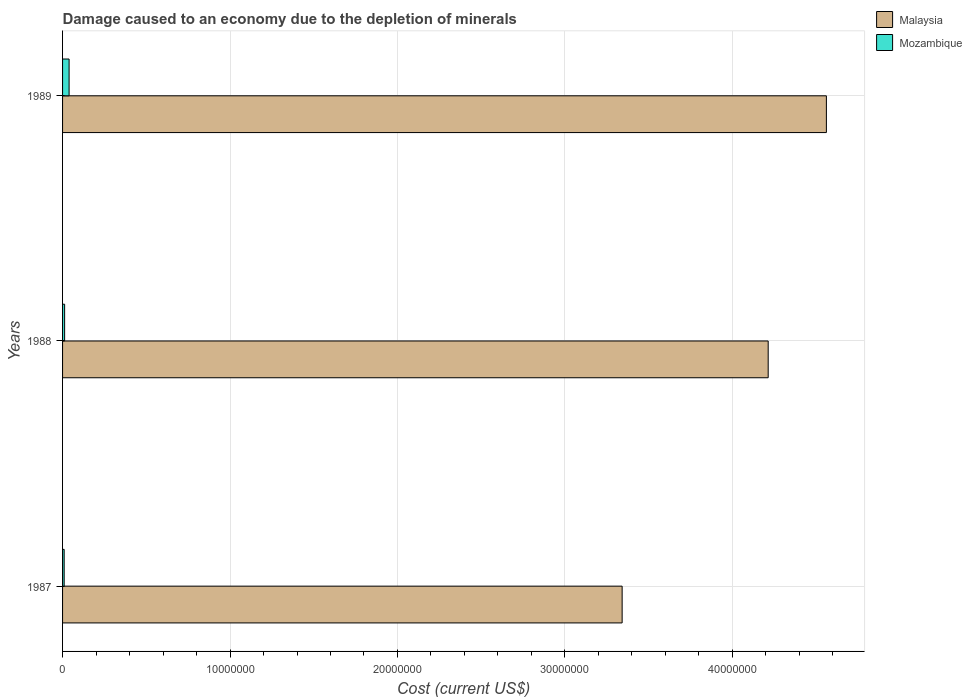How many different coloured bars are there?
Your answer should be compact. 2. How many groups of bars are there?
Your answer should be compact. 3. Are the number of bars on each tick of the Y-axis equal?
Ensure brevity in your answer.  Yes. What is the label of the 3rd group of bars from the top?
Give a very brief answer. 1987. What is the cost of damage caused due to the depletion of minerals in Malaysia in 1987?
Give a very brief answer. 3.34e+07. Across all years, what is the maximum cost of damage caused due to the depletion of minerals in Malaysia?
Your answer should be compact. 4.56e+07. Across all years, what is the minimum cost of damage caused due to the depletion of minerals in Mozambique?
Offer a terse response. 9.63e+04. In which year was the cost of damage caused due to the depletion of minerals in Mozambique maximum?
Offer a very short reply. 1989. What is the total cost of damage caused due to the depletion of minerals in Mozambique in the graph?
Your answer should be very brief. 6.10e+05. What is the difference between the cost of damage caused due to the depletion of minerals in Malaysia in 1987 and that in 1988?
Ensure brevity in your answer.  -8.72e+06. What is the difference between the cost of damage caused due to the depletion of minerals in Malaysia in 1987 and the cost of damage caused due to the depletion of minerals in Mozambique in 1989?
Keep it short and to the point. 3.30e+07. What is the average cost of damage caused due to the depletion of minerals in Mozambique per year?
Keep it short and to the point. 2.03e+05. In the year 1987, what is the difference between the cost of damage caused due to the depletion of minerals in Malaysia and cost of damage caused due to the depletion of minerals in Mozambique?
Offer a terse response. 3.33e+07. In how many years, is the cost of damage caused due to the depletion of minerals in Mozambique greater than 18000000 US$?
Keep it short and to the point. 0. What is the ratio of the cost of damage caused due to the depletion of minerals in Malaysia in 1987 to that in 1988?
Give a very brief answer. 0.79. Is the difference between the cost of damage caused due to the depletion of minerals in Malaysia in 1987 and 1988 greater than the difference between the cost of damage caused due to the depletion of minerals in Mozambique in 1987 and 1988?
Offer a very short reply. No. What is the difference between the highest and the second highest cost of damage caused due to the depletion of minerals in Mozambique?
Ensure brevity in your answer.  2.66e+05. What is the difference between the highest and the lowest cost of damage caused due to the depletion of minerals in Malaysia?
Provide a short and direct response. 1.22e+07. What does the 2nd bar from the top in 1989 represents?
Keep it short and to the point. Malaysia. What does the 1st bar from the bottom in 1987 represents?
Offer a very short reply. Malaysia. How many bars are there?
Your response must be concise. 6. How many years are there in the graph?
Keep it short and to the point. 3. What is the difference between two consecutive major ticks on the X-axis?
Offer a terse response. 1.00e+07. Are the values on the major ticks of X-axis written in scientific E-notation?
Provide a short and direct response. No. How are the legend labels stacked?
Provide a succinct answer. Vertical. What is the title of the graph?
Your response must be concise. Damage caused to an economy due to the depletion of minerals. What is the label or title of the X-axis?
Your answer should be compact. Cost (current US$). What is the label or title of the Y-axis?
Ensure brevity in your answer.  Years. What is the Cost (current US$) of Malaysia in 1987?
Your answer should be very brief. 3.34e+07. What is the Cost (current US$) in Mozambique in 1987?
Provide a succinct answer. 9.63e+04. What is the Cost (current US$) of Malaysia in 1988?
Your answer should be very brief. 4.21e+07. What is the Cost (current US$) in Mozambique in 1988?
Ensure brevity in your answer.  1.23e+05. What is the Cost (current US$) of Malaysia in 1989?
Keep it short and to the point. 4.56e+07. What is the Cost (current US$) in Mozambique in 1989?
Keep it short and to the point. 3.90e+05. Across all years, what is the maximum Cost (current US$) of Malaysia?
Your answer should be compact. 4.56e+07. Across all years, what is the maximum Cost (current US$) in Mozambique?
Offer a very short reply. 3.90e+05. Across all years, what is the minimum Cost (current US$) in Malaysia?
Your answer should be very brief. 3.34e+07. Across all years, what is the minimum Cost (current US$) in Mozambique?
Provide a short and direct response. 9.63e+04. What is the total Cost (current US$) in Malaysia in the graph?
Keep it short and to the point. 1.21e+08. What is the total Cost (current US$) in Mozambique in the graph?
Your answer should be very brief. 6.10e+05. What is the difference between the Cost (current US$) of Malaysia in 1987 and that in 1988?
Offer a terse response. -8.72e+06. What is the difference between the Cost (current US$) of Mozambique in 1987 and that in 1988?
Your answer should be very brief. -2.72e+04. What is the difference between the Cost (current US$) of Malaysia in 1987 and that in 1989?
Ensure brevity in your answer.  -1.22e+07. What is the difference between the Cost (current US$) of Mozambique in 1987 and that in 1989?
Provide a short and direct response. -2.94e+05. What is the difference between the Cost (current US$) in Malaysia in 1988 and that in 1989?
Ensure brevity in your answer.  -3.48e+06. What is the difference between the Cost (current US$) of Mozambique in 1988 and that in 1989?
Provide a short and direct response. -2.66e+05. What is the difference between the Cost (current US$) in Malaysia in 1987 and the Cost (current US$) in Mozambique in 1988?
Keep it short and to the point. 3.33e+07. What is the difference between the Cost (current US$) in Malaysia in 1987 and the Cost (current US$) in Mozambique in 1989?
Keep it short and to the point. 3.30e+07. What is the difference between the Cost (current US$) in Malaysia in 1988 and the Cost (current US$) in Mozambique in 1989?
Your answer should be compact. 4.17e+07. What is the average Cost (current US$) in Malaysia per year?
Your answer should be compact. 4.04e+07. What is the average Cost (current US$) of Mozambique per year?
Provide a short and direct response. 2.03e+05. In the year 1987, what is the difference between the Cost (current US$) in Malaysia and Cost (current US$) in Mozambique?
Make the answer very short. 3.33e+07. In the year 1988, what is the difference between the Cost (current US$) of Malaysia and Cost (current US$) of Mozambique?
Provide a short and direct response. 4.20e+07. In the year 1989, what is the difference between the Cost (current US$) in Malaysia and Cost (current US$) in Mozambique?
Give a very brief answer. 4.52e+07. What is the ratio of the Cost (current US$) in Malaysia in 1987 to that in 1988?
Offer a very short reply. 0.79. What is the ratio of the Cost (current US$) of Mozambique in 1987 to that in 1988?
Give a very brief answer. 0.78. What is the ratio of the Cost (current US$) in Malaysia in 1987 to that in 1989?
Offer a terse response. 0.73. What is the ratio of the Cost (current US$) of Mozambique in 1987 to that in 1989?
Make the answer very short. 0.25. What is the ratio of the Cost (current US$) in Malaysia in 1988 to that in 1989?
Give a very brief answer. 0.92. What is the ratio of the Cost (current US$) of Mozambique in 1988 to that in 1989?
Provide a succinct answer. 0.32. What is the difference between the highest and the second highest Cost (current US$) in Malaysia?
Offer a terse response. 3.48e+06. What is the difference between the highest and the second highest Cost (current US$) in Mozambique?
Ensure brevity in your answer.  2.66e+05. What is the difference between the highest and the lowest Cost (current US$) of Malaysia?
Your answer should be very brief. 1.22e+07. What is the difference between the highest and the lowest Cost (current US$) of Mozambique?
Offer a terse response. 2.94e+05. 